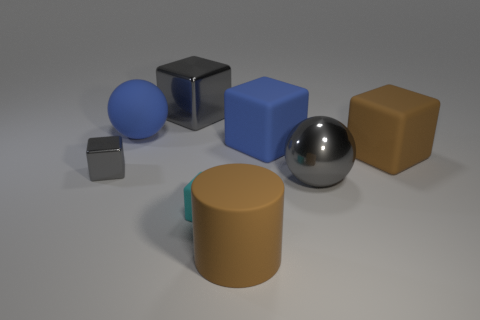Subtract 1 blocks. How many blocks are left? 4 Subtract all brown cubes. How many cubes are left? 4 Subtract all blue cubes. How many cubes are left? 4 Subtract all green cubes. Subtract all cyan spheres. How many cubes are left? 5 Add 1 brown matte objects. How many objects exist? 9 Subtract all balls. How many objects are left? 6 Subtract 1 brown cylinders. How many objects are left? 7 Subtract all blocks. Subtract all blue blocks. How many objects are left? 2 Add 7 small gray blocks. How many small gray blocks are left? 8 Add 2 large spheres. How many large spheres exist? 4 